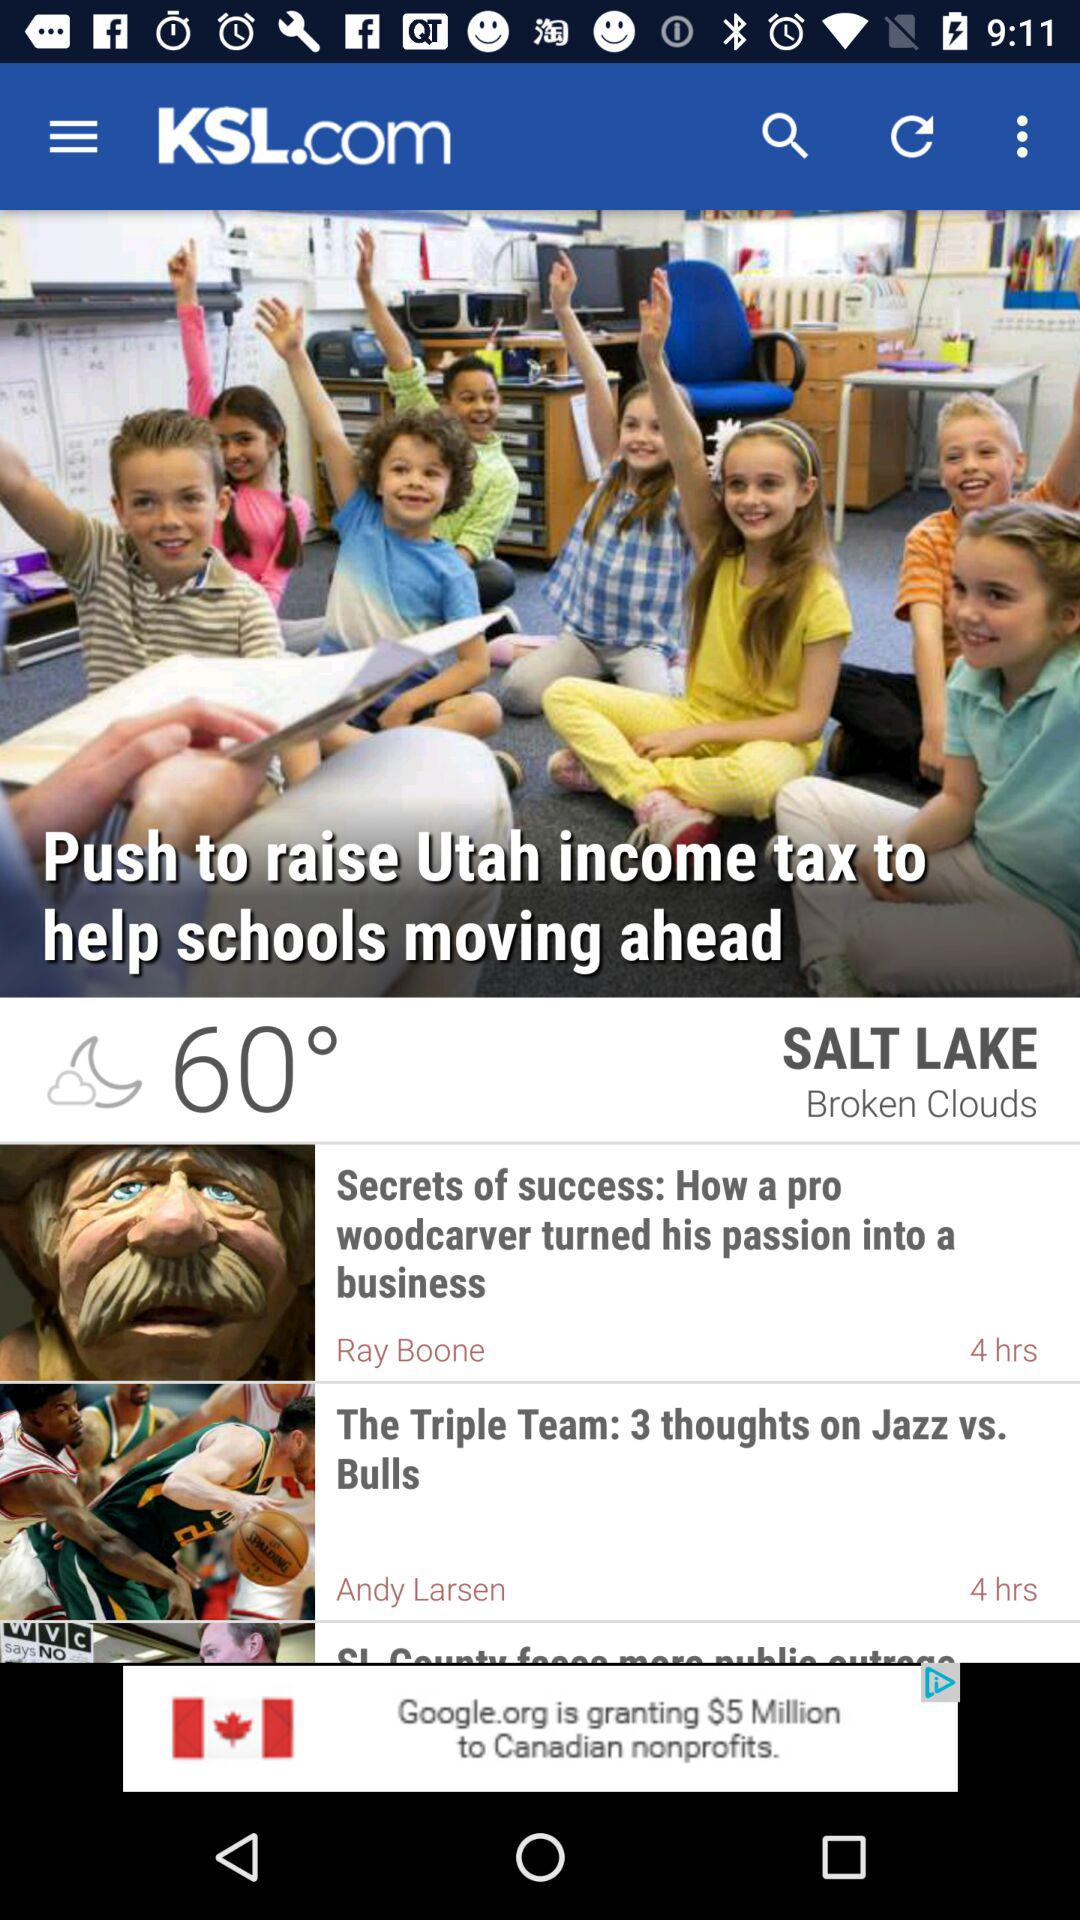What is the heading of the article posted 4 hours ago by Ray Boone? The heading of the article is "Secrets of success: How a pro woodcarver turned his passion into a business". 